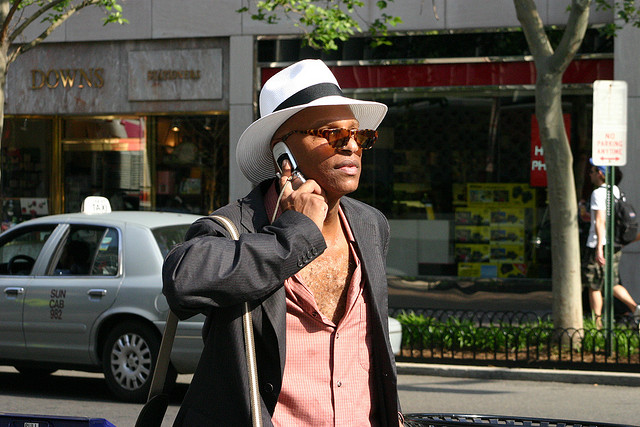<image>What is the sign of the man in the background? I am not sure what the sign of the man in the background is. It can be 'downs', 'no parking', 'no parking anytime', 'parking', or 'capricorn'. What is the man watching? I am not sure what the man is watching. It could be traffic, a bus, the path he is walking on, or people. What is the man watching? I am not sure what the man is watching. It can be traffic, bus, or people. What is the sign of the man in the background? I don't know what is the sign of the man in the background. It can be 'downs', 'no parking', 'no parking anytime', 'parking', or 'capricorn'. 